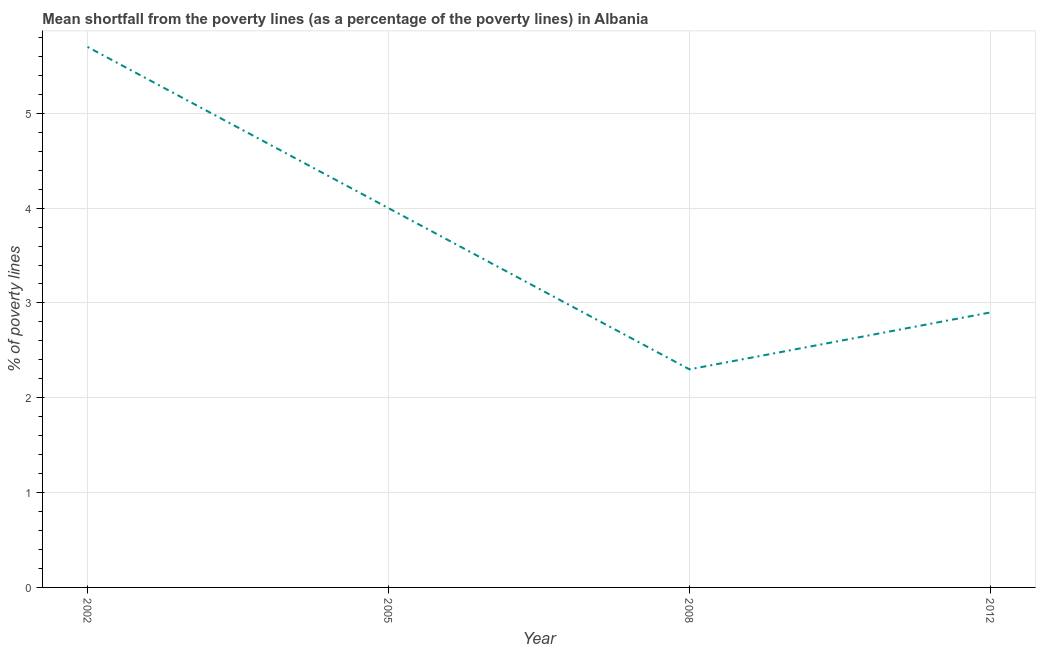Across all years, what is the maximum poverty gap at national poverty lines?
Offer a terse response. 5.7. Across all years, what is the minimum poverty gap at national poverty lines?
Your response must be concise. 2.3. In which year was the poverty gap at national poverty lines maximum?
Offer a terse response. 2002. In which year was the poverty gap at national poverty lines minimum?
Your answer should be very brief. 2008. What is the sum of the poverty gap at national poverty lines?
Keep it short and to the point. 14.9. What is the difference between the poverty gap at national poverty lines in 2005 and 2008?
Offer a terse response. 1.7. What is the average poverty gap at national poverty lines per year?
Keep it short and to the point. 3.73. What is the median poverty gap at national poverty lines?
Make the answer very short. 3.45. What is the ratio of the poverty gap at national poverty lines in 2005 to that in 2008?
Your answer should be compact. 1.74. Is the poverty gap at national poverty lines in 2002 less than that in 2005?
Your answer should be compact. No. Is the difference between the poverty gap at national poverty lines in 2005 and 2008 greater than the difference between any two years?
Your answer should be very brief. No. What is the difference between the highest and the second highest poverty gap at national poverty lines?
Offer a terse response. 1.7. What is the difference between the highest and the lowest poverty gap at national poverty lines?
Ensure brevity in your answer.  3.4. Does the poverty gap at national poverty lines monotonically increase over the years?
Offer a terse response. No. How many years are there in the graph?
Give a very brief answer. 4. Does the graph contain any zero values?
Your answer should be compact. No. What is the title of the graph?
Your answer should be compact. Mean shortfall from the poverty lines (as a percentage of the poverty lines) in Albania. What is the label or title of the Y-axis?
Make the answer very short. % of poverty lines. What is the % of poverty lines in 2002?
Keep it short and to the point. 5.7. What is the difference between the % of poverty lines in 2002 and 2005?
Provide a succinct answer. 1.7. What is the difference between the % of poverty lines in 2002 and 2008?
Offer a very short reply. 3.4. What is the difference between the % of poverty lines in 2002 and 2012?
Ensure brevity in your answer.  2.8. What is the difference between the % of poverty lines in 2005 and 2008?
Your answer should be compact. 1.7. What is the difference between the % of poverty lines in 2005 and 2012?
Offer a terse response. 1.1. What is the ratio of the % of poverty lines in 2002 to that in 2005?
Provide a short and direct response. 1.43. What is the ratio of the % of poverty lines in 2002 to that in 2008?
Make the answer very short. 2.48. What is the ratio of the % of poverty lines in 2002 to that in 2012?
Ensure brevity in your answer.  1.97. What is the ratio of the % of poverty lines in 2005 to that in 2008?
Keep it short and to the point. 1.74. What is the ratio of the % of poverty lines in 2005 to that in 2012?
Keep it short and to the point. 1.38. What is the ratio of the % of poverty lines in 2008 to that in 2012?
Offer a terse response. 0.79. 